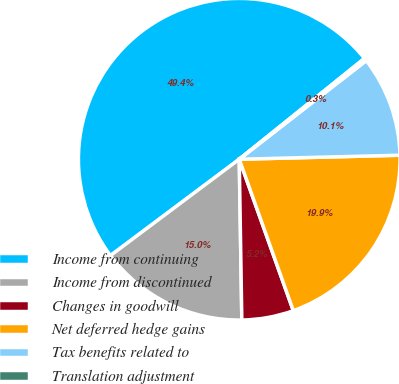Convert chart to OTSL. <chart><loc_0><loc_0><loc_500><loc_500><pie_chart><fcel>Income from continuing<fcel>Income from discontinued<fcel>Changes in goodwill<fcel>Net deferred hedge gains<fcel>Tax benefits related to<fcel>Translation adjustment<nl><fcel>49.43%<fcel>15.03%<fcel>5.2%<fcel>19.94%<fcel>10.11%<fcel>0.28%<nl></chart> 